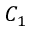Convert formula to latex. <formula><loc_0><loc_0><loc_500><loc_500>C _ { 1 }</formula> 